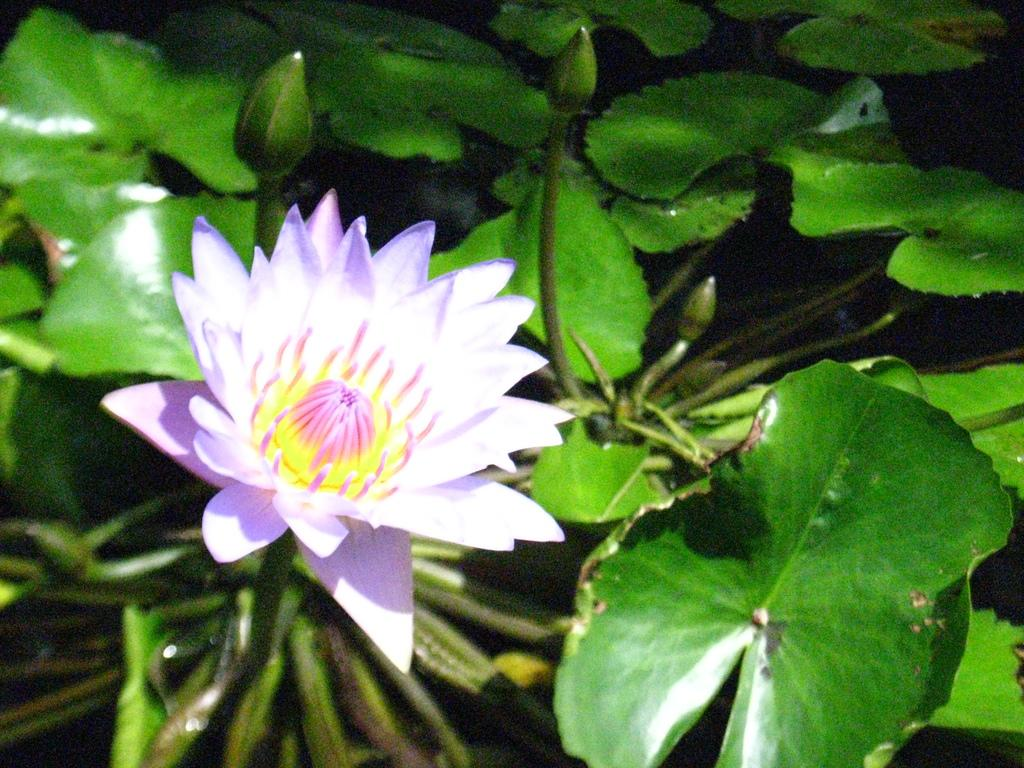What is the plant doing in the water? The plant is submerged in the water. What part of the plant is visible in the image? The plant has a flower that is visible. What type of memory can be seen in the image? There is no memory present in the image; it features a plant in the water with a flower. What type of fruit is hanging from the plant in the image? There is no fruit present on the plant in the image; it only has a flower. 